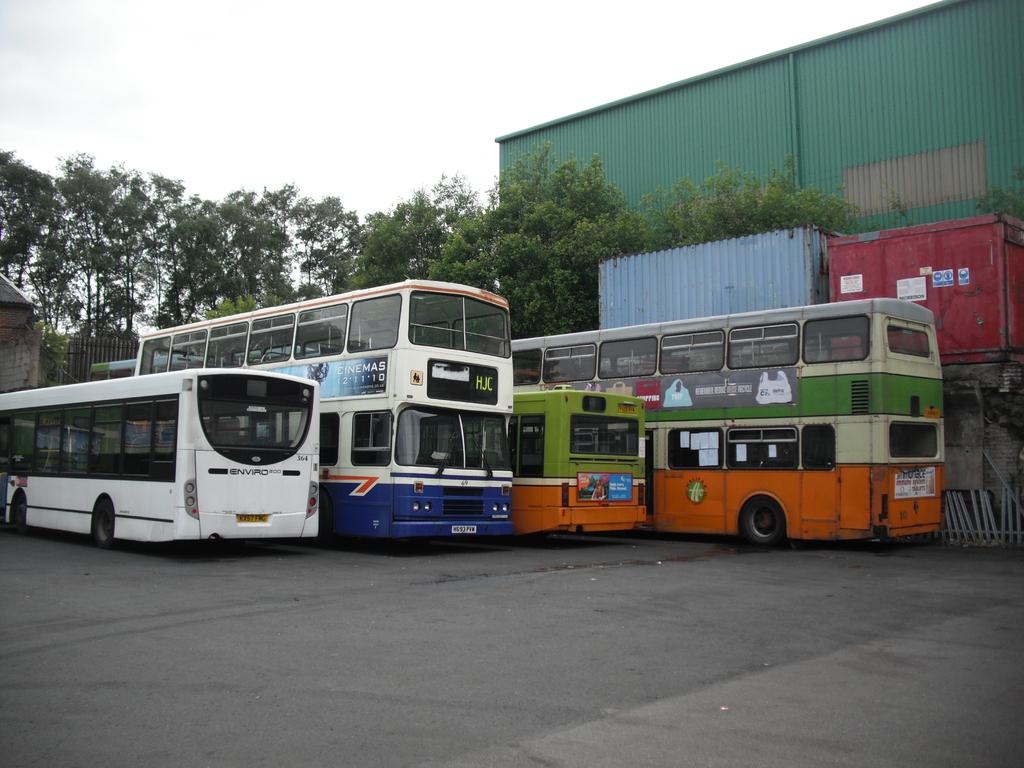How many buses are in the image? There are two buses in the image. What type of buses are in the image? There are two double-decker buses in the image. Where are the buses located in the image? The buses are on the floor. What can be seen in the background of the image? Trees, containers, and the sky are visible in the background of the image. What type of crack is visible on the buses in the image? There is no crack visible on the buses in the image. What kind of plate is being used to serve food on the buses in the image? There is no plate present in the image, as it is focused on the buses themselves. 